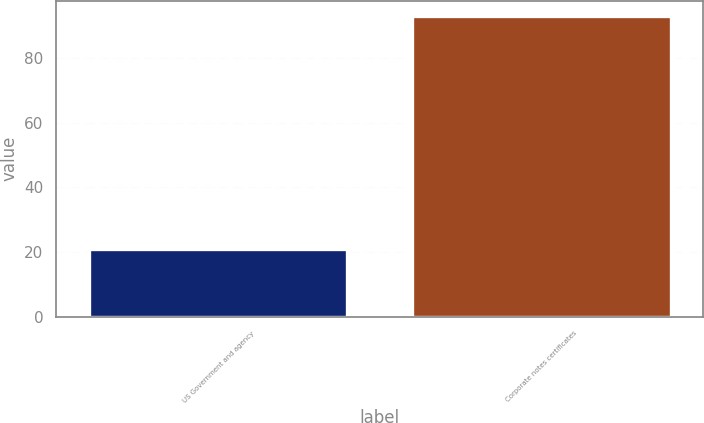<chart> <loc_0><loc_0><loc_500><loc_500><bar_chart><fcel>US Government and agency<fcel>Corporate notes certificates<nl><fcel>21<fcel>93<nl></chart> 